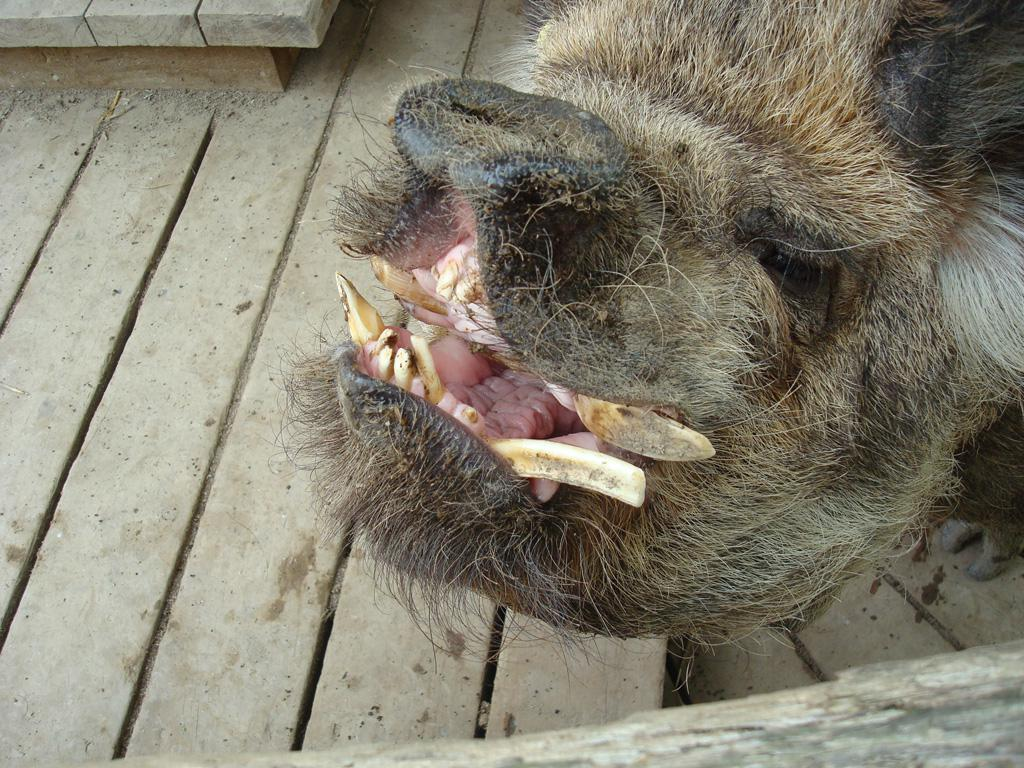What type of creature is in the image? There is an animal in the image. Can you describe the surface the animal is on? The animal is on a wooden surface. How much honey is the animal carrying in the image? There is no honey present in the image, and the animal is not carrying anything. 